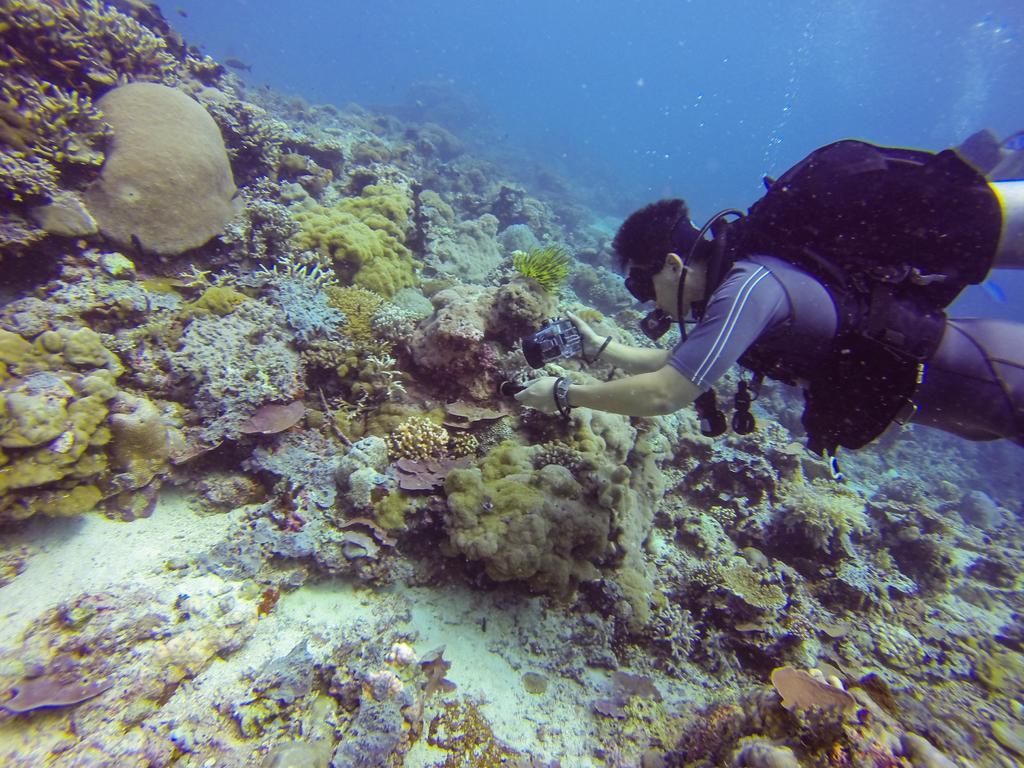In one or two sentences, can you explain what this image depicts? In this image, we can see a person holding an object is in the water. We can also see some water plants. 